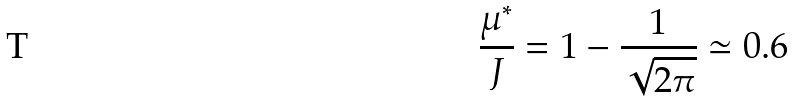<formula> <loc_0><loc_0><loc_500><loc_500>\frac { \mu ^ { * } } { J } = 1 - \frac { 1 } { \sqrt { 2 \pi } } \simeq 0 . 6</formula> 